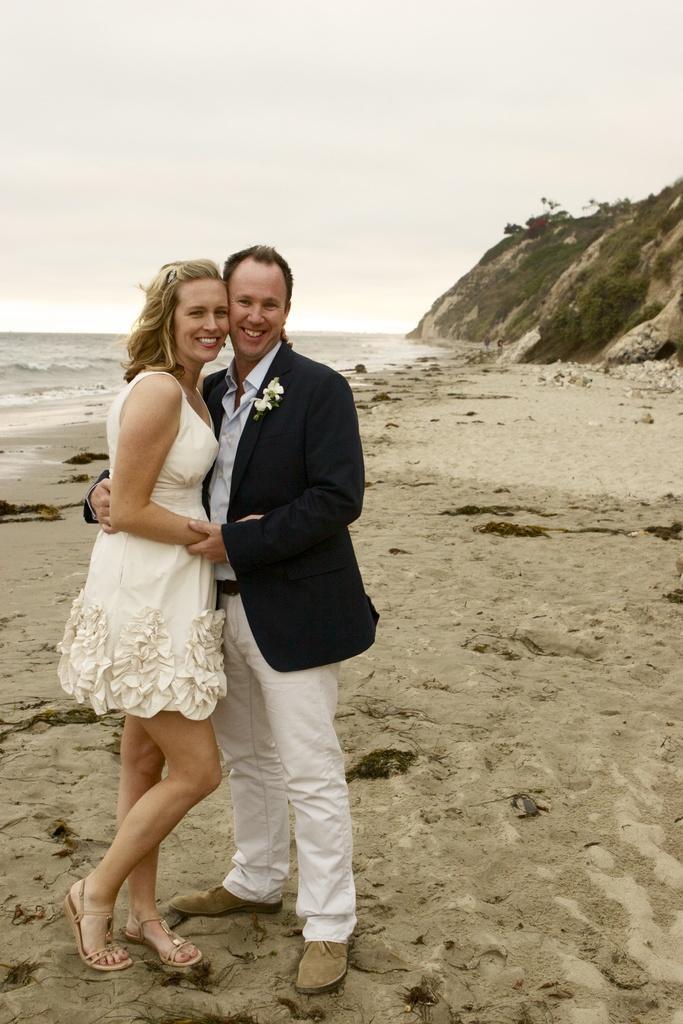Can you describe this image briefly? In this picture we can see a man and a woman are standing and smiling, at the bottom there is mug, on the right side we can see a hill and plants, on the left side there is water, we can see the sky at the top of the picture. 